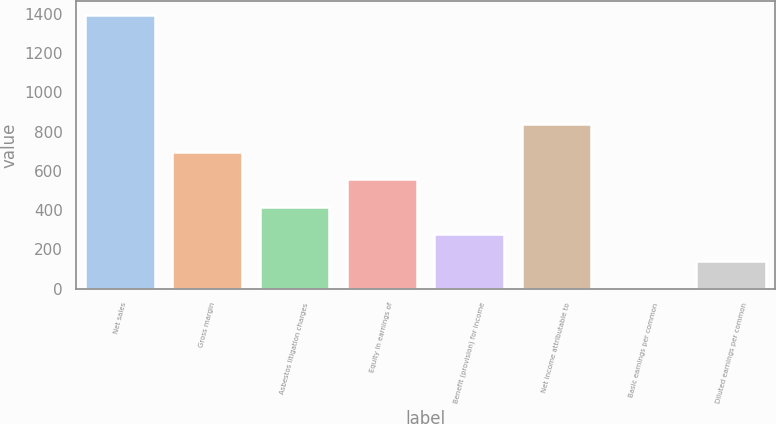Convert chart. <chart><loc_0><loc_0><loc_500><loc_500><bar_chart><fcel>Net sales<fcel>Gross margin<fcel>Asbestos litigation charges<fcel>Equity in earnings of<fcel>Benefit (provision) for income<fcel>Net income attributable to<fcel>Basic earnings per common<fcel>Diluted earnings per common<nl><fcel>1395<fcel>697.69<fcel>418.77<fcel>558.23<fcel>279.31<fcel>837.15<fcel>0.39<fcel>139.85<nl></chart> 